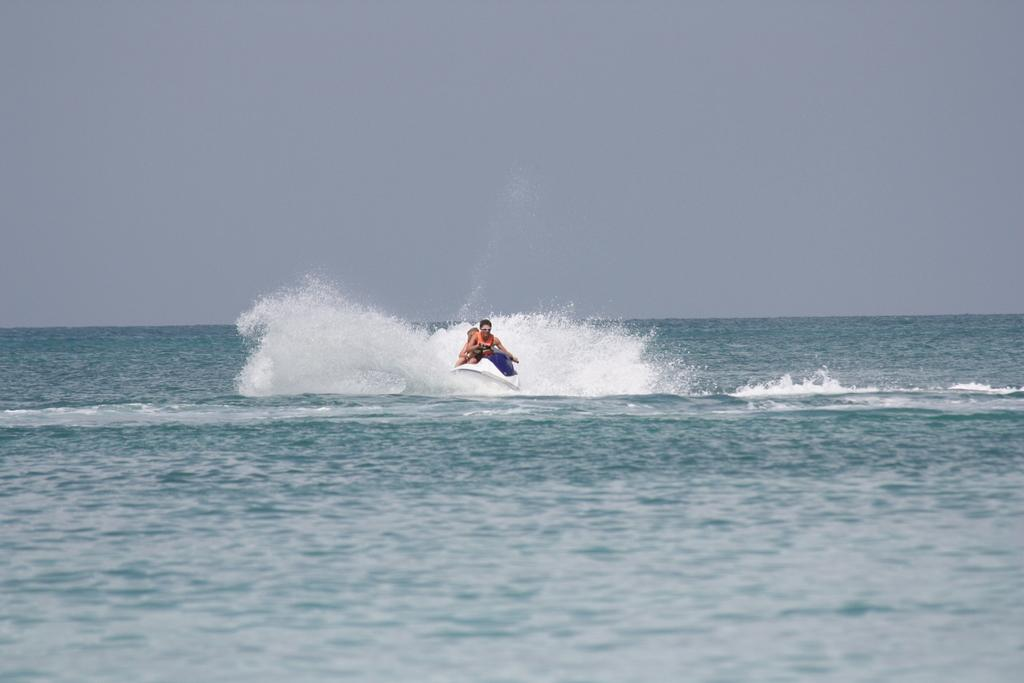How many people are in the image? There are two persons in the image. What activity are the two persons engaged in? The two persons are boating. What can be seen below the boat in the image? The surface of the sea is visible in the image. Where is the boating activity taking place? The sea is the location of the boating activity. What is visible in the background of the image? The sky is visible in the background of the image. What type of memory is being used to support the boat in the image? There is no memory or support structure visible in the image; the boat is floating on the surface of the sea. 